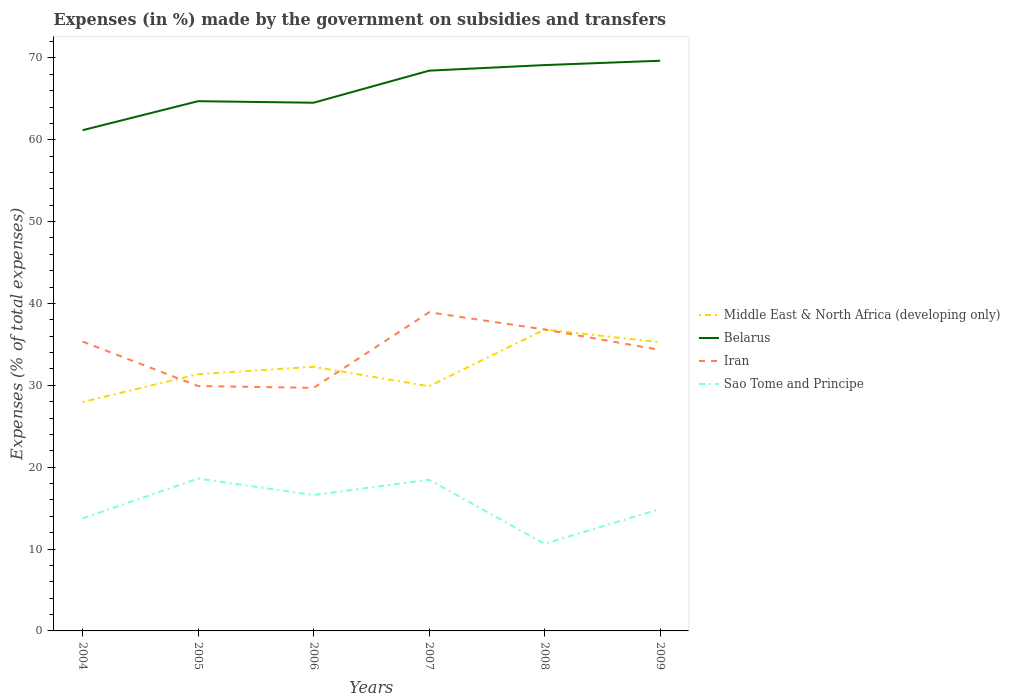How many different coloured lines are there?
Give a very brief answer. 4. Across all years, what is the maximum percentage of expenses made by the government on subsidies and transfers in Sao Tome and Principe?
Offer a very short reply. 10.63. What is the total percentage of expenses made by the government on subsidies and transfers in Iran in the graph?
Your answer should be very brief. -7.13. What is the difference between the highest and the second highest percentage of expenses made by the government on subsidies and transfers in Middle East & North Africa (developing only)?
Offer a very short reply. 8.86. How many lines are there?
Your answer should be compact. 4. How many years are there in the graph?
Provide a succinct answer. 6. Does the graph contain any zero values?
Ensure brevity in your answer.  No. Where does the legend appear in the graph?
Your answer should be very brief. Center right. How many legend labels are there?
Your response must be concise. 4. What is the title of the graph?
Provide a succinct answer. Expenses (in %) made by the government on subsidies and transfers. Does "Palau" appear as one of the legend labels in the graph?
Provide a short and direct response. No. What is the label or title of the X-axis?
Offer a very short reply. Years. What is the label or title of the Y-axis?
Ensure brevity in your answer.  Expenses (% of total expenses). What is the Expenses (% of total expenses) in Middle East & North Africa (developing only) in 2004?
Your answer should be very brief. 27.96. What is the Expenses (% of total expenses) in Belarus in 2004?
Make the answer very short. 61.16. What is the Expenses (% of total expenses) in Iran in 2004?
Your answer should be very brief. 35.34. What is the Expenses (% of total expenses) of Sao Tome and Principe in 2004?
Keep it short and to the point. 13.74. What is the Expenses (% of total expenses) of Middle East & North Africa (developing only) in 2005?
Keep it short and to the point. 31.37. What is the Expenses (% of total expenses) in Belarus in 2005?
Your answer should be very brief. 64.71. What is the Expenses (% of total expenses) in Iran in 2005?
Ensure brevity in your answer.  29.91. What is the Expenses (% of total expenses) in Sao Tome and Principe in 2005?
Provide a succinct answer. 18.61. What is the Expenses (% of total expenses) in Middle East & North Africa (developing only) in 2006?
Your answer should be very brief. 32.26. What is the Expenses (% of total expenses) of Belarus in 2006?
Offer a terse response. 64.52. What is the Expenses (% of total expenses) in Iran in 2006?
Your response must be concise. 29.69. What is the Expenses (% of total expenses) in Sao Tome and Principe in 2006?
Offer a terse response. 16.6. What is the Expenses (% of total expenses) of Middle East & North Africa (developing only) in 2007?
Your answer should be compact. 29.88. What is the Expenses (% of total expenses) in Belarus in 2007?
Offer a very short reply. 68.44. What is the Expenses (% of total expenses) of Iran in 2007?
Keep it short and to the point. 38.93. What is the Expenses (% of total expenses) of Sao Tome and Principe in 2007?
Make the answer very short. 18.47. What is the Expenses (% of total expenses) in Middle East & North Africa (developing only) in 2008?
Your response must be concise. 36.82. What is the Expenses (% of total expenses) in Belarus in 2008?
Make the answer very short. 69.12. What is the Expenses (% of total expenses) of Iran in 2008?
Keep it short and to the point. 36.82. What is the Expenses (% of total expenses) in Sao Tome and Principe in 2008?
Give a very brief answer. 10.63. What is the Expenses (% of total expenses) of Middle East & North Africa (developing only) in 2009?
Your answer should be compact. 35.26. What is the Expenses (% of total expenses) in Belarus in 2009?
Offer a very short reply. 69.65. What is the Expenses (% of total expenses) in Iran in 2009?
Your answer should be very brief. 34.32. What is the Expenses (% of total expenses) of Sao Tome and Principe in 2009?
Give a very brief answer. 14.9. Across all years, what is the maximum Expenses (% of total expenses) in Middle East & North Africa (developing only)?
Your answer should be very brief. 36.82. Across all years, what is the maximum Expenses (% of total expenses) of Belarus?
Offer a terse response. 69.65. Across all years, what is the maximum Expenses (% of total expenses) in Iran?
Your answer should be very brief. 38.93. Across all years, what is the maximum Expenses (% of total expenses) of Sao Tome and Principe?
Provide a short and direct response. 18.61. Across all years, what is the minimum Expenses (% of total expenses) in Middle East & North Africa (developing only)?
Provide a short and direct response. 27.96. Across all years, what is the minimum Expenses (% of total expenses) in Belarus?
Your answer should be very brief. 61.16. Across all years, what is the minimum Expenses (% of total expenses) of Iran?
Offer a very short reply. 29.69. Across all years, what is the minimum Expenses (% of total expenses) in Sao Tome and Principe?
Make the answer very short. 10.63. What is the total Expenses (% of total expenses) in Middle East & North Africa (developing only) in the graph?
Make the answer very short. 193.56. What is the total Expenses (% of total expenses) in Belarus in the graph?
Give a very brief answer. 397.61. What is the total Expenses (% of total expenses) of Iran in the graph?
Provide a short and direct response. 205.01. What is the total Expenses (% of total expenses) of Sao Tome and Principe in the graph?
Your response must be concise. 92.95. What is the difference between the Expenses (% of total expenses) of Middle East & North Africa (developing only) in 2004 and that in 2005?
Give a very brief answer. -3.4. What is the difference between the Expenses (% of total expenses) in Belarus in 2004 and that in 2005?
Provide a short and direct response. -3.55. What is the difference between the Expenses (% of total expenses) of Iran in 2004 and that in 2005?
Your answer should be compact. 5.43. What is the difference between the Expenses (% of total expenses) of Sao Tome and Principe in 2004 and that in 2005?
Your answer should be compact. -4.87. What is the difference between the Expenses (% of total expenses) of Middle East & North Africa (developing only) in 2004 and that in 2006?
Keep it short and to the point. -4.3. What is the difference between the Expenses (% of total expenses) in Belarus in 2004 and that in 2006?
Your answer should be compact. -3.36. What is the difference between the Expenses (% of total expenses) of Iran in 2004 and that in 2006?
Make the answer very short. 5.65. What is the difference between the Expenses (% of total expenses) in Sao Tome and Principe in 2004 and that in 2006?
Your answer should be very brief. -2.85. What is the difference between the Expenses (% of total expenses) in Middle East & North Africa (developing only) in 2004 and that in 2007?
Ensure brevity in your answer.  -1.92. What is the difference between the Expenses (% of total expenses) in Belarus in 2004 and that in 2007?
Provide a short and direct response. -7.28. What is the difference between the Expenses (% of total expenses) in Iran in 2004 and that in 2007?
Your answer should be very brief. -3.58. What is the difference between the Expenses (% of total expenses) in Sao Tome and Principe in 2004 and that in 2007?
Your answer should be very brief. -4.73. What is the difference between the Expenses (% of total expenses) in Middle East & North Africa (developing only) in 2004 and that in 2008?
Ensure brevity in your answer.  -8.86. What is the difference between the Expenses (% of total expenses) in Belarus in 2004 and that in 2008?
Ensure brevity in your answer.  -7.96. What is the difference between the Expenses (% of total expenses) in Iran in 2004 and that in 2008?
Provide a succinct answer. -1.48. What is the difference between the Expenses (% of total expenses) of Sao Tome and Principe in 2004 and that in 2008?
Provide a short and direct response. 3.11. What is the difference between the Expenses (% of total expenses) of Middle East & North Africa (developing only) in 2004 and that in 2009?
Make the answer very short. -7.3. What is the difference between the Expenses (% of total expenses) of Belarus in 2004 and that in 2009?
Ensure brevity in your answer.  -8.49. What is the difference between the Expenses (% of total expenses) in Iran in 2004 and that in 2009?
Offer a terse response. 1.03. What is the difference between the Expenses (% of total expenses) in Sao Tome and Principe in 2004 and that in 2009?
Keep it short and to the point. -1.15. What is the difference between the Expenses (% of total expenses) in Middle East & North Africa (developing only) in 2005 and that in 2006?
Make the answer very short. -0.9. What is the difference between the Expenses (% of total expenses) of Belarus in 2005 and that in 2006?
Your response must be concise. 0.19. What is the difference between the Expenses (% of total expenses) in Iran in 2005 and that in 2006?
Your answer should be very brief. 0.22. What is the difference between the Expenses (% of total expenses) of Sao Tome and Principe in 2005 and that in 2006?
Ensure brevity in your answer.  2.01. What is the difference between the Expenses (% of total expenses) in Middle East & North Africa (developing only) in 2005 and that in 2007?
Your answer should be very brief. 1.48. What is the difference between the Expenses (% of total expenses) of Belarus in 2005 and that in 2007?
Your response must be concise. -3.73. What is the difference between the Expenses (% of total expenses) of Iran in 2005 and that in 2007?
Provide a succinct answer. -9.01. What is the difference between the Expenses (% of total expenses) in Sao Tome and Principe in 2005 and that in 2007?
Your answer should be very brief. 0.14. What is the difference between the Expenses (% of total expenses) in Middle East & North Africa (developing only) in 2005 and that in 2008?
Your answer should be compact. -5.45. What is the difference between the Expenses (% of total expenses) in Belarus in 2005 and that in 2008?
Provide a succinct answer. -4.41. What is the difference between the Expenses (% of total expenses) of Iran in 2005 and that in 2008?
Your answer should be very brief. -6.91. What is the difference between the Expenses (% of total expenses) in Sao Tome and Principe in 2005 and that in 2008?
Offer a terse response. 7.98. What is the difference between the Expenses (% of total expenses) in Middle East & North Africa (developing only) in 2005 and that in 2009?
Ensure brevity in your answer.  -3.89. What is the difference between the Expenses (% of total expenses) of Belarus in 2005 and that in 2009?
Provide a short and direct response. -4.94. What is the difference between the Expenses (% of total expenses) in Iran in 2005 and that in 2009?
Your answer should be compact. -4.4. What is the difference between the Expenses (% of total expenses) in Sao Tome and Principe in 2005 and that in 2009?
Make the answer very short. 3.71. What is the difference between the Expenses (% of total expenses) of Middle East & North Africa (developing only) in 2006 and that in 2007?
Make the answer very short. 2.38. What is the difference between the Expenses (% of total expenses) of Belarus in 2006 and that in 2007?
Your response must be concise. -3.92. What is the difference between the Expenses (% of total expenses) in Iran in 2006 and that in 2007?
Offer a terse response. -9.23. What is the difference between the Expenses (% of total expenses) in Sao Tome and Principe in 2006 and that in 2007?
Provide a succinct answer. -1.87. What is the difference between the Expenses (% of total expenses) of Middle East & North Africa (developing only) in 2006 and that in 2008?
Ensure brevity in your answer.  -4.56. What is the difference between the Expenses (% of total expenses) of Belarus in 2006 and that in 2008?
Provide a short and direct response. -4.6. What is the difference between the Expenses (% of total expenses) in Iran in 2006 and that in 2008?
Ensure brevity in your answer.  -7.13. What is the difference between the Expenses (% of total expenses) in Sao Tome and Principe in 2006 and that in 2008?
Provide a short and direct response. 5.96. What is the difference between the Expenses (% of total expenses) of Middle East & North Africa (developing only) in 2006 and that in 2009?
Keep it short and to the point. -3. What is the difference between the Expenses (% of total expenses) in Belarus in 2006 and that in 2009?
Ensure brevity in your answer.  -5.13. What is the difference between the Expenses (% of total expenses) in Iran in 2006 and that in 2009?
Give a very brief answer. -4.62. What is the difference between the Expenses (% of total expenses) in Sao Tome and Principe in 2006 and that in 2009?
Give a very brief answer. 1.7. What is the difference between the Expenses (% of total expenses) in Middle East & North Africa (developing only) in 2007 and that in 2008?
Your answer should be compact. -6.94. What is the difference between the Expenses (% of total expenses) in Belarus in 2007 and that in 2008?
Offer a terse response. -0.68. What is the difference between the Expenses (% of total expenses) of Iran in 2007 and that in 2008?
Offer a terse response. 2.1. What is the difference between the Expenses (% of total expenses) of Sao Tome and Principe in 2007 and that in 2008?
Keep it short and to the point. 7.84. What is the difference between the Expenses (% of total expenses) in Middle East & North Africa (developing only) in 2007 and that in 2009?
Ensure brevity in your answer.  -5.38. What is the difference between the Expenses (% of total expenses) in Belarus in 2007 and that in 2009?
Keep it short and to the point. -1.21. What is the difference between the Expenses (% of total expenses) of Iran in 2007 and that in 2009?
Your answer should be compact. 4.61. What is the difference between the Expenses (% of total expenses) in Sao Tome and Principe in 2007 and that in 2009?
Ensure brevity in your answer.  3.57. What is the difference between the Expenses (% of total expenses) of Middle East & North Africa (developing only) in 2008 and that in 2009?
Keep it short and to the point. 1.56. What is the difference between the Expenses (% of total expenses) in Belarus in 2008 and that in 2009?
Your answer should be very brief. -0.53. What is the difference between the Expenses (% of total expenses) of Iran in 2008 and that in 2009?
Your response must be concise. 2.5. What is the difference between the Expenses (% of total expenses) in Sao Tome and Principe in 2008 and that in 2009?
Give a very brief answer. -4.26. What is the difference between the Expenses (% of total expenses) in Middle East & North Africa (developing only) in 2004 and the Expenses (% of total expenses) in Belarus in 2005?
Ensure brevity in your answer.  -36.75. What is the difference between the Expenses (% of total expenses) of Middle East & North Africa (developing only) in 2004 and the Expenses (% of total expenses) of Iran in 2005?
Your answer should be compact. -1.95. What is the difference between the Expenses (% of total expenses) in Middle East & North Africa (developing only) in 2004 and the Expenses (% of total expenses) in Sao Tome and Principe in 2005?
Provide a short and direct response. 9.36. What is the difference between the Expenses (% of total expenses) in Belarus in 2004 and the Expenses (% of total expenses) in Iran in 2005?
Offer a terse response. 31.25. What is the difference between the Expenses (% of total expenses) in Belarus in 2004 and the Expenses (% of total expenses) in Sao Tome and Principe in 2005?
Your answer should be very brief. 42.56. What is the difference between the Expenses (% of total expenses) in Iran in 2004 and the Expenses (% of total expenses) in Sao Tome and Principe in 2005?
Make the answer very short. 16.74. What is the difference between the Expenses (% of total expenses) of Middle East & North Africa (developing only) in 2004 and the Expenses (% of total expenses) of Belarus in 2006?
Your answer should be compact. -36.56. What is the difference between the Expenses (% of total expenses) in Middle East & North Africa (developing only) in 2004 and the Expenses (% of total expenses) in Iran in 2006?
Give a very brief answer. -1.73. What is the difference between the Expenses (% of total expenses) of Middle East & North Africa (developing only) in 2004 and the Expenses (% of total expenses) of Sao Tome and Principe in 2006?
Provide a short and direct response. 11.37. What is the difference between the Expenses (% of total expenses) in Belarus in 2004 and the Expenses (% of total expenses) in Iran in 2006?
Offer a terse response. 31.47. What is the difference between the Expenses (% of total expenses) of Belarus in 2004 and the Expenses (% of total expenses) of Sao Tome and Principe in 2006?
Ensure brevity in your answer.  44.57. What is the difference between the Expenses (% of total expenses) in Iran in 2004 and the Expenses (% of total expenses) in Sao Tome and Principe in 2006?
Ensure brevity in your answer.  18.75. What is the difference between the Expenses (% of total expenses) of Middle East & North Africa (developing only) in 2004 and the Expenses (% of total expenses) of Belarus in 2007?
Make the answer very short. -40.48. What is the difference between the Expenses (% of total expenses) in Middle East & North Africa (developing only) in 2004 and the Expenses (% of total expenses) in Iran in 2007?
Ensure brevity in your answer.  -10.96. What is the difference between the Expenses (% of total expenses) of Middle East & North Africa (developing only) in 2004 and the Expenses (% of total expenses) of Sao Tome and Principe in 2007?
Your answer should be compact. 9.49. What is the difference between the Expenses (% of total expenses) of Belarus in 2004 and the Expenses (% of total expenses) of Iran in 2007?
Your answer should be compact. 22.24. What is the difference between the Expenses (% of total expenses) of Belarus in 2004 and the Expenses (% of total expenses) of Sao Tome and Principe in 2007?
Your response must be concise. 42.69. What is the difference between the Expenses (% of total expenses) in Iran in 2004 and the Expenses (% of total expenses) in Sao Tome and Principe in 2007?
Your answer should be very brief. 16.88. What is the difference between the Expenses (% of total expenses) in Middle East & North Africa (developing only) in 2004 and the Expenses (% of total expenses) in Belarus in 2008?
Make the answer very short. -41.16. What is the difference between the Expenses (% of total expenses) in Middle East & North Africa (developing only) in 2004 and the Expenses (% of total expenses) in Iran in 2008?
Make the answer very short. -8.86. What is the difference between the Expenses (% of total expenses) of Middle East & North Africa (developing only) in 2004 and the Expenses (% of total expenses) of Sao Tome and Principe in 2008?
Provide a succinct answer. 17.33. What is the difference between the Expenses (% of total expenses) of Belarus in 2004 and the Expenses (% of total expenses) of Iran in 2008?
Make the answer very short. 24.34. What is the difference between the Expenses (% of total expenses) of Belarus in 2004 and the Expenses (% of total expenses) of Sao Tome and Principe in 2008?
Provide a short and direct response. 50.53. What is the difference between the Expenses (% of total expenses) of Iran in 2004 and the Expenses (% of total expenses) of Sao Tome and Principe in 2008?
Your response must be concise. 24.71. What is the difference between the Expenses (% of total expenses) of Middle East & North Africa (developing only) in 2004 and the Expenses (% of total expenses) of Belarus in 2009?
Ensure brevity in your answer.  -41.69. What is the difference between the Expenses (% of total expenses) of Middle East & North Africa (developing only) in 2004 and the Expenses (% of total expenses) of Iran in 2009?
Ensure brevity in your answer.  -6.35. What is the difference between the Expenses (% of total expenses) in Middle East & North Africa (developing only) in 2004 and the Expenses (% of total expenses) in Sao Tome and Principe in 2009?
Your answer should be compact. 13.07. What is the difference between the Expenses (% of total expenses) of Belarus in 2004 and the Expenses (% of total expenses) of Iran in 2009?
Your answer should be compact. 26.85. What is the difference between the Expenses (% of total expenses) in Belarus in 2004 and the Expenses (% of total expenses) in Sao Tome and Principe in 2009?
Offer a very short reply. 46.27. What is the difference between the Expenses (% of total expenses) of Iran in 2004 and the Expenses (% of total expenses) of Sao Tome and Principe in 2009?
Your answer should be very brief. 20.45. What is the difference between the Expenses (% of total expenses) of Middle East & North Africa (developing only) in 2005 and the Expenses (% of total expenses) of Belarus in 2006?
Give a very brief answer. -33.16. What is the difference between the Expenses (% of total expenses) in Middle East & North Africa (developing only) in 2005 and the Expenses (% of total expenses) in Iran in 2006?
Keep it short and to the point. 1.67. What is the difference between the Expenses (% of total expenses) in Middle East & North Africa (developing only) in 2005 and the Expenses (% of total expenses) in Sao Tome and Principe in 2006?
Give a very brief answer. 14.77. What is the difference between the Expenses (% of total expenses) of Belarus in 2005 and the Expenses (% of total expenses) of Iran in 2006?
Provide a succinct answer. 35.02. What is the difference between the Expenses (% of total expenses) of Belarus in 2005 and the Expenses (% of total expenses) of Sao Tome and Principe in 2006?
Ensure brevity in your answer.  48.11. What is the difference between the Expenses (% of total expenses) of Iran in 2005 and the Expenses (% of total expenses) of Sao Tome and Principe in 2006?
Provide a succinct answer. 13.32. What is the difference between the Expenses (% of total expenses) of Middle East & North Africa (developing only) in 2005 and the Expenses (% of total expenses) of Belarus in 2007?
Offer a very short reply. -37.07. What is the difference between the Expenses (% of total expenses) in Middle East & North Africa (developing only) in 2005 and the Expenses (% of total expenses) in Iran in 2007?
Ensure brevity in your answer.  -7.56. What is the difference between the Expenses (% of total expenses) in Middle East & North Africa (developing only) in 2005 and the Expenses (% of total expenses) in Sao Tome and Principe in 2007?
Give a very brief answer. 12.9. What is the difference between the Expenses (% of total expenses) of Belarus in 2005 and the Expenses (% of total expenses) of Iran in 2007?
Offer a terse response. 25.78. What is the difference between the Expenses (% of total expenses) of Belarus in 2005 and the Expenses (% of total expenses) of Sao Tome and Principe in 2007?
Your answer should be very brief. 46.24. What is the difference between the Expenses (% of total expenses) of Iran in 2005 and the Expenses (% of total expenses) of Sao Tome and Principe in 2007?
Give a very brief answer. 11.44. What is the difference between the Expenses (% of total expenses) in Middle East & North Africa (developing only) in 2005 and the Expenses (% of total expenses) in Belarus in 2008?
Ensure brevity in your answer.  -37.75. What is the difference between the Expenses (% of total expenses) of Middle East & North Africa (developing only) in 2005 and the Expenses (% of total expenses) of Iran in 2008?
Keep it short and to the point. -5.45. What is the difference between the Expenses (% of total expenses) in Middle East & North Africa (developing only) in 2005 and the Expenses (% of total expenses) in Sao Tome and Principe in 2008?
Provide a succinct answer. 20.73. What is the difference between the Expenses (% of total expenses) in Belarus in 2005 and the Expenses (% of total expenses) in Iran in 2008?
Ensure brevity in your answer.  27.89. What is the difference between the Expenses (% of total expenses) of Belarus in 2005 and the Expenses (% of total expenses) of Sao Tome and Principe in 2008?
Your response must be concise. 54.08. What is the difference between the Expenses (% of total expenses) in Iran in 2005 and the Expenses (% of total expenses) in Sao Tome and Principe in 2008?
Keep it short and to the point. 19.28. What is the difference between the Expenses (% of total expenses) in Middle East & North Africa (developing only) in 2005 and the Expenses (% of total expenses) in Belarus in 2009?
Offer a terse response. -38.28. What is the difference between the Expenses (% of total expenses) of Middle East & North Africa (developing only) in 2005 and the Expenses (% of total expenses) of Iran in 2009?
Your response must be concise. -2.95. What is the difference between the Expenses (% of total expenses) in Middle East & North Africa (developing only) in 2005 and the Expenses (% of total expenses) in Sao Tome and Principe in 2009?
Give a very brief answer. 16.47. What is the difference between the Expenses (% of total expenses) of Belarus in 2005 and the Expenses (% of total expenses) of Iran in 2009?
Give a very brief answer. 30.39. What is the difference between the Expenses (% of total expenses) of Belarus in 2005 and the Expenses (% of total expenses) of Sao Tome and Principe in 2009?
Keep it short and to the point. 49.81. What is the difference between the Expenses (% of total expenses) in Iran in 2005 and the Expenses (% of total expenses) in Sao Tome and Principe in 2009?
Give a very brief answer. 15.02. What is the difference between the Expenses (% of total expenses) in Middle East & North Africa (developing only) in 2006 and the Expenses (% of total expenses) in Belarus in 2007?
Make the answer very short. -36.17. What is the difference between the Expenses (% of total expenses) of Middle East & North Africa (developing only) in 2006 and the Expenses (% of total expenses) of Iran in 2007?
Make the answer very short. -6.66. What is the difference between the Expenses (% of total expenses) of Middle East & North Africa (developing only) in 2006 and the Expenses (% of total expenses) of Sao Tome and Principe in 2007?
Your answer should be compact. 13.79. What is the difference between the Expenses (% of total expenses) in Belarus in 2006 and the Expenses (% of total expenses) in Iran in 2007?
Make the answer very short. 25.6. What is the difference between the Expenses (% of total expenses) in Belarus in 2006 and the Expenses (% of total expenses) in Sao Tome and Principe in 2007?
Give a very brief answer. 46.05. What is the difference between the Expenses (% of total expenses) of Iran in 2006 and the Expenses (% of total expenses) of Sao Tome and Principe in 2007?
Make the answer very short. 11.22. What is the difference between the Expenses (% of total expenses) in Middle East & North Africa (developing only) in 2006 and the Expenses (% of total expenses) in Belarus in 2008?
Offer a very short reply. -36.86. What is the difference between the Expenses (% of total expenses) in Middle East & North Africa (developing only) in 2006 and the Expenses (% of total expenses) in Iran in 2008?
Offer a very short reply. -4.56. What is the difference between the Expenses (% of total expenses) of Middle East & North Africa (developing only) in 2006 and the Expenses (% of total expenses) of Sao Tome and Principe in 2008?
Offer a very short reply. 21.63. What is the difference between the Expenses (% of total expenses) in Belarus in 2006 and the Expenses (% of total expenses) in Iran in 2008?
Provide a succinct answer. 27.7. What is the difference between the Expenses (% of total expenses) in Belarus in 2006 and the Expenses (% of total expenses) in Sao Tome and Principe in 2008?
Provide a succinct answer. 53.89. What is the difference between the Expenses (% of total expenses) in Iran in 2006 and the Expenses (% of total expenses) in Sao Tome and Principe in 2008?
Your response must be concise. 19.06. What is the difference between the Expenses (% of total expenses) in Middle East & North Africa (developing only) in 2006 and the Expenses (% of total expenses) in Belarus in 2009?
Your response must be concise. -37.39. What is the difference between the Expenses (% of total expenses) in Middle East & North Africa (developing only) in 2006 and the Expenses (% of total expenses) in Iran in 2009?
Give a very brief answer. -2.05. What is the difference between the Expenses (% of total expenses) in Middle East & North Africa (developing only) in 2006 and the Expenses (% of total expenses) in Sao Tome and Principe in 2009?
Your answer should be very brief. 17.37. What is the difference between the Expenses (% of total expenses) of Belarus in 2006 and the Expenses (% of total expenses) of Iran in 2009?
Ensure brevity in your answer.  30.21. What is the difference between the Expenses (% of total expenses) in Belarus in 2006 and the Expenses (% of total expenses) in Sao Tome and Principe in 2009?
Provide a short and direct response. 49.63. What is the difference between the Expenses (% of total expenses) of Iran in 2006 and the Expenses (% of total expenses) of Sao Tome and Principe in 2009?
Offer a very short reply. 14.8. What is the difference between the Expenses (% of total expenses) of Middle East & North Africa (developing only) in 2007 and the Expenses (% of total expenses) of Belarus in 2008?
Offer a terse response. -39.24. What is the difference between the Expenses (% of total expenses) of Middle East & North Africa (developing only) in 2007 and the Expenses (% of total expenses) of Iran in 2008?
Provide a short and direct response. -6.94. What is the difference between the Expenses (% of total expenses) in Middle East & North Africa (developing only) in 2007 and the Expenses (% of total expenses) in Sao Tome and Principe in 2008?
Ensure brevity in your answer.  19.25. What is the difference between the Expenses (% of total expenses) in Belarus in 2007 and the Expenses (% of total expenses) in Iran in 2008?
Provide a short and direct response. 31.62. What is the difference between the Expenses (% of total expenses) of Belarus in 2007 and the Expenses (% of total expenses) of Sao Tome and Principe in 2008?
Ensure brevity in your answer.  57.81. What is the difference between the Expenses (% of total expenses) in Iran in 2007 and the Expenses (% of total expenses) in Sao Tome and Principe in 2008?
Your answer should be compact. 28.29. What is the difference between the Expenses (% of total expenses) in Middle East & North Africa (developing only) in 2007 and the Expenses (% of total expenses) in Belarus in 2009?
Keep it short and to the point. -39.77. What is the difference between the Expenses (% of total expenses) of Middle East & North Africa (developing only) in 2007 and the Expenses (% of total expenses) of Iran in 2009?
Your answer should be compact. -4.43. What is the difference between the Expenses (% of total expenses) of Middle East & North Africa (developing only) in 2007 and the Expenses (% of total expenses) of Sao Tome and Principe in 2009?
Give a very brief answer. 14.99. What is the difference between the Expenses (% of total expenses) in Belarus in 2007 and the Expenses (% of total expenses) in Iran in 2009?
Keep it short and to the point. 34.12. What is the difference between the Expenses (% of total expenses) in Belarus in 2007 and the Expenses (% of total expenses) in Sao Tome and Principe in 2009?
Provide a succinct answer. 53.54. What is the difference between the Expenses (% of total expenses) in Iran in 2007 and the Expenses (% of total expenses) in Sao Tome and Principe in 2009?
Give a very brief answer. 24.03. What is the difference between the Expenses (% of total expenses) in Middle East & North Africa (developing only) in 2008 and the Expenses (% of total expenses) in Belarus in 2009?
Your answer should be very brief. -32.83. What is the difference between the Expenses (% of total expenses) in Middle East & North Africa (developing only) in 2008 and the Expenses (% of total expenses) in Iran in 2009?
Your response must be concise. 2.5. What is the difference between the Expenses (% of total expenses) of Middle East & North Africa (developing only) in 2008 and the Expenses (% of total expenses) of Sao Tome and Principe in 2009?
Offer a very short reply. 21.92. What is the difference between the Expenses (% of total expenses) of Belarus in 2008 and the Expenses (% of total expenses) of Iran in 2009?
Offer a very short reply. 34.8. What is the difference between the Expenses (% of total expenses) of Belarus in 2008 and the Expenses (% of total expenses) of Sao Tome and Principe in 2009?
Provide a short and direct response. 54.22. What is the difference between the Expenses (% of total expenses) of Iran in 2008 and the Expenses (% of total expenses) of Sao Tome and Principe in 2009?
Your answer should be very brief. 21.92. What is the average Expenses (% of total expenses) of Middle East & North Africa (developing only) per year?
Offer a very short reply. 32.26. What is the average Expenses (% of total expenses) of Belarus per year?
Keep it short and to the point. 66.27. What is the average Expenses (% of total expenses) of Iran per year?
Ensure brevity in your answer.  34.17. What is the average Expenses (% of total expenses) of Sao Tome and Principe per year?
Keep it short and to the point. 15.49. In the year 2004, what is the difference between the Expenses (% of total expenses) in Middle East & North Africa (developing only) and Expenses (% of total expenses) in Belarus?
Provide a succinct answer. -33.2. In the year 2004, what is the difference between the Expenses (% of total expenses) of Middle East & North Africa (developing only) and Expenses (% of total expenses) of Iran?
Keep it short and to the point. -7.38. In the year 2004, what is the difference between the Expenses (% of total expenses) in Middle East & North Africa (developing only) and Expenses (% of total expenses) in Sao Tome and Principe?
Your answer should be very brief. 14.22. In the year 2004, what is the difference between the Expenses (% of total expenses) of Belarus and Expenses (% of total expenses) of Iran?
Give a very brief answer. 25.82. In the year 2004, what is the difference between the Expenses (% of total expenses) of Belarus and Expenses (% of total expenses) of Sao Tome and Principe?
Offer a terse response. 47.42. In the year 2004, what is the difference between the Expenses (% of total expenses) of Iran and Expenses (% of total expenses) of Sao Tome and Principe?
Offer a terse response. 21.6. In the year 2005, what is the difference between the Expenses (% of total expenses) in Middle East & North Africa (developing only) and Expenses (% of total expenses) in Belarus?
Make the answer very short. -33.34. In the year 2005, what is the difference between the Expenses (% of total expenses) in Middle East & North Africa (developing only) and Expenses (% of total expenses) in Iran?
Offer a very short reply. 1.45. In the year 2005, what is the difference between the Expenses (% of total expenses) in Middle East & North Africa (developing only) and Expenses (% of total expenses) in Sao Tome and Principe?
Your response must be concise. 12.76. In the year 2005, what is the difference between the Expenses (% of total expenses) in Belarus and Expenses (% of total expenses) in Iran?
Your response must be concise. 34.8. In the year 2005, what is the difference between the Expenses (% of total expenses) of Belarus and Expenses (% of total expenses) of Sao Tome and Principe?
Provide a short and direct response. 46.1. In the year 2005, what is the difference between the Expenses (% of total expenses) in Iran and Expenses (% of total expenses) in Sao Tome and Principe?
Your answer should be very brief. 11.3. In the year 2006, what is the difference between the Expenses (% of total expenses) of Middle East & North Africa (developing only) and Expenses (% of total expenses) of Belarus?
Your answer should be compact. -32.26. In the year 2006, what is the difference between the Expenses (% of total expenses) in Middle East & North Africa (developing only) and Expenses (% of total expenses) in Iran?
Offer a terse response. 2.57. In the year 2006, what is the difference between the Expenses (% of total expenses) in Middle East & North Africa (developing only) and Expenses (% of total expenses) in Sao Tome and Principe?
Give a very brief answer. 15.67. In the year 2006, what is the difference between the Expenses (% of total expenses) of Belarus and Expenses (% of total expenses) of Iran?
Offer a very short reply. 34.83. In the year 2006, what is the difference between the Expenses (% of total expenses) in Belarus and Expenses (% of total expenses) in Sao Tome and Principe?
Ensure brevity in your answer.  47.93. In the year 2006, what is the difference between the Expenses (% of total expenses) in Iran and Expenses (% of total expenses) in Sao Tome and Principe?
Your response must be concise. 13.09. In the year 2007, what is the difference between the Expenses (% of total expenses) in Middle East & North Africa (developing only) and Expenses (% of total expenses) in Belarus?
Keep it short and to the point. -38.55. In the year 2007, what is the difference between the Expenses (% of total expenses) in Middle East & North Africa (developing only) and Expenses (% of total expenses) in Iran?
Your response must be concise. -9.04. In the year 2007, what is the difference between the Expenses (% of total expenses) in Middle East & North Africa (developing only) and Expenses (% of total expenses) in Sao Tome and Principe?
Ensure brevity in your answer.  11.41. In the year 2007, what is the difference between the Expenses (% of total expenses) in Belarus and Expenses (% of total expenses) in Iran?
Your response must be concise. 29.51. In the year 2007, what is the difference between the Expenses (% of total expenses) in Belarus and Expenses (% of total expenses) in Sao Tome and Principe?
Your answer should be compact. 49.97. In the year 2007, what is the difference between the Expenses (% of total expenses) in Iran and Expenses (% of total expenses) in Sao Tome and Principe?
Make the answer very short. 20.46. In the year 2008, what is the difference between the Expenses (% of total expenses) of Middle East & North Africa (developing only) and Expenses (% of total expenses) of Belarus?
Your response must be concise. -32.3. In the year 2008, what is the difference between the Expenses (% of total expenses) in Middle East & North Africa (developing only) and Expenses (% of total expenses) in Sao Tome and Principe?
Your answer should be compact. 26.19. In the year 2008, what is the difference between the Expenses (% of total expenses) of Belarus and Expenses (% of total expenses) of Iran?
Keep it short and to the point. 32.3. In the year 2008, what is the difference between the Expenses (% of total expenses) in Belarus and Expenses (% of total expenses) in Sao Tome and Principe?
Your answer should be very brief. 58.49. In the year 2008, what is the difference between the Expenses (% of total expenses) of Iran and Expenses (% of total expenses) of Sao Tome and Principe?
Your answer should be very brief. 26.19. In the year 2009, what is the difference between the Expenses (% of total expenses) in Middle East & North Africa (developing only) and Expenses (% of total expenses) in Belarus?
Your answer should be very brief. -34.39. In the year 2009, what is the difference between the Expenses (% of total expenses) of Middle East & North Africa (developing only) and Expenses (% of total expenses) of Iran?
Provide a succinct answer. 0.94. In the year 2009, what is the difference between the Expenses (% of total expenses) of Middle East & North Africa (developing only) and Expenses (% of total expenses) of Sao Tome and Principe?
Make the answer very short. 20.36. In the year 2009, what is the difference between the Expenses (% of total expenses) of Belarus and Expenses (% of total expenses) of Iran?
Your response must be concise. 35.34. In the year 2009, what is the difference between the Expenses (% of total expenses) of Belarus and Expenses (% of total expenses) of Sao Tome and Principe?
Your answer should be compact. 54.75. In the year 2009, what is the difference between the Expenses (% of total expenses) of Iran and Expenses (% of total expenses) of Sao Tome and Principe?
Offer a very short reply. 19.42. What is the ratio of the Expenses (% of total expenses) in Middle East & North Africa (developing only) in 2004 to that in 2005?
Make the answer very short. 0.89. What is the ratio of the Expenses (% of total expenses) in Belarus in 2004 to that in 2005?
Keep it short and to the point. 0.95. What is the ratio of the Expenses (% of total expenses) of Iran in 2004 to that in 2005?
Make the answer very short. 1.18. What is the ratio of the Expenses (% of total expenses) of Sao Tome and Principe in 2004 to that in 2005?
Your answer should be compact. 0.74. What is the ratio of the Expenses (% of total expenses) of Middle East & North Africa (developing only) in 2004 to that in 2006?
Make the answer very short. 0.87. What is the ratio of the Expenses (% of total expenses) of Belarus in 2004 to that in 2006?
Ensure brevity in your answer.  0.95. What is the ratio of the Expenses (% of total expenses) of Iran in 2004 to that in 2006?
Offer a terse response. 1.19. What is the ratio of the Expenses (% of total expenses) in Sao Tome and Principe in 2004 to that in 2006?
Ensure brevity in your answer.  0.83. What is the ratio of the Expenses (% of total expenses) of Middle East & North Africa (developing only) in 2004 to that in 2007?
Offer a terse response. 0.94. What is the ratio of the Expenses (% of total expenses) of Belarus in 2004 to that in 2007?
Give a very brief answer. 0.89. What is the ratio of the Expenses (% of total expenses) of Iran in 2004 to that in 2007?
Offer a terse response. 0.91. What is the ratio of the Expenses (% of total expenses) of Sao Tome and Principe in 2004 to that in 2007?
Offer a terse response. 0.74. What is the ratio of the Expenses (% of total expenses) of Middle East & North Africa (developing only) in 2004 to that in 2008?
Offer a very short reply. 0.76. What is the ratio of the Expenses (% of total expenses) in Belarus in 2004 to that in 2008?
Make the answer very short. 0.88. What is the ratio of the Expenses (% of total expenses) of Iran in 2004 to that in 2008?
Provide a succinct answer. 0.96. What is the ratio of the Expenses (% of total expenses) of Sao Tome and Principe in 2004 to that in 2008?
Provide a succinct answer. 1.29. What is the ratio of the Expenses (% of total expenses) in Middle East & North Africa (developing only) in 2004 to that in 2009?
Offer a terse response. 0.79. What is the ratio of the Expenses (% of total expenses) in Belarus in 2004 to that in 2009?
Your answer should be compact. 0.88. What is the ratio of the Expenses (% of total expenses) of Iran in 2004 to that in 2009?
Ensure brevity in your answer.  1.03. What is the ratio of the Expenses (% of total expenses) of Sao Tome and Principe in 2004 to that in 2009?
Your answer should be compact. 0.92. What is the ratio of the Expenses (% of total expenses) in Middle East & North Africa (developing only) in 2005 to that in 2006?
Give a very brief answer. 0.97. What is the ratio of the Expenses (% of total expenses) in Belarus in 2005 to that in 2006?
Provide a succinct answer. 1. What is the ratio of the Expenses (% of total expenses) of Iran in 2005 to that in 2006?
Provide a short and direct response. 1.01. What is the ratio of the Expenses (% of total expenses) of Sao Tome and Principe in 2005 to that in 2006?
Provide a succinct answer. 1.12. What is the ratio of the Expenses (% of total expenses) of Middle East & North Africa (developing only) in 2005 to that in 2007?
Make the answer very short. 1.05. What is the ratio of the Expenses (% of total expenses) in Belarus in 2005 to that in 2007?
Offer a very short reply. 0.95. What is the ratio of the Expenses (% of total expenses) in Iran in 2005 to that in 2007?
Ensure brevity in your answer.  0.77. What is the ratio of the Expenses (% of total expenses) of Sao Tome and Principe in 2005 to that in 2007?
Give a very brief answer. 1.01. What is the ratio of the Expenses (% of total expenses) in Middle East & North Africa (developing only) in 2005 to that in 2008?
Your answer should be compact. 0.85. What is the ratio of the Expenses (% of total expenses) of Belarus in 2005 to that in 2008?
Offer a terse response. 0.94. What is the ratio of the Expenses (% of total expenses) of Iran in 2005 to that in 2008?
Make the answer very short. 0.81. What is the ratio of the Expenses (% of total expenses) of Middle East & North Africa (developing only) in 2005 to that in 2009?
Offer a very short reply. 0.89. What is the ratio of the Expenses (% of total expenses) in Belarus in 2005 to that in 2009?
Ensure brevity in your answer.  0.93. What is the ratio of the Expenses (% of total expenses) in Iran in 2005 to that in 2009?
Keep it short and to the point. 0.87. What is the ratio of the Expenses (% of total expenses) in Sao Tome and Principe in 2005 to that in 2009?
Make the answer very short. 1.25. What is the ratio of the Expenses (% of total expenses) of Middle East & North Africa (developing only) in 2006 to that in 2007?
Make the answer very short. 1.08. What is the ratio of the Expenses (% of total expenses) of Belarus in 2006 to that in 2007?
Keep it short and to the point. 0.94. What is the ratio of the Expenses (% of total expenses) in Iran in 2006 to that in 2007?
Offer a terse response. 0.76. What is the ratio of the Expenses (% of total expenses) of Sao Tome and Principe in 2006 to that in 2007?
Provide a short and direct response. 0.9. What is the ratio of the Expenses (% of total expenses) of Middle East & North Africa (developing only) in 2006 to that in 2008?
Offer a terse response. 0.88. What is the ratio of the Expenses (% of total expenses) of Belarus in 2006 to that in 2008?
Your answer should be very brief. 0.93. What is the ratio of the Expenses (% of total expenses) of Iran in 2006 to that in 2008?
Make the answer very short. 0.81. What is the ratio of the Expenses (% of total expenses) of Sao Tome and Principe in 2006 to that in 2008?
Offer a terse response. 1.56. What is the ratio of the Expenses (% of total expenses) of Middle East & North Africa (developing only) in 2006 to that in 2009?
Offer a very short reply. 0.92. What is the ratio of the Expenses (% of total expenses) in Belarus in 2006 to that in 2009?
Your answer should be compact. 0.93. What is the ratio of the Expenses (% of total expenses) of Iran in 2006 to that in 2009?
Your answer should be compact. 0.87. What is the ratio of the Expenses (% of total expenses) in Sao Tome and Principe in 2006 to that in 2009?
Your response must be concise. 1.11. What is the ratio of the Expenses (% of total expenses) in Middle East & North Africa (developing only) in 2007 to that in 2008?
Make the answer very short. 0.81. What is the ratio of the Expenses (% of total expenses) in Belarus in 2007 to that in 2008?
Your answer should be compact. 0.99. What is the ratio of the Expenses (% of total expenses) of Iran in 2007 to that in 2008?
Your answer should be very brief. 1.06. What is the ratio of the Expenses (% of total expenses) of Sao Tome and Principe in 2007 to that in 2008?
Make the answer very short. 1.74. What is the ratio of the Expenses (% of total expenses) of Middle East & North Africa (developing only) in 2007 to that in 2009?
Make the answer very short. 0.85. What is the ratio of the Expenses (% of total expenses) of Belarus in 2007 to that in 2009?
Make the answer very short. 0.98. What is the ratio of the Expenses (% of total expenses) of Iran in 2007 to that in 2009?
Keep it short and to the point. 1.13. What is the ratio of the Expenses (% of total expenses) of Sao Tome and Principe in 2007 to that in 2009?
Provide a succinct answer. 1.24. What is the ratio of the Expenses (% of total expenses) in Middle East & North Africa (developing only) in 2008 to that in 2009?
Ensure brevity in your answer.  1.04. What is the ratio of the Expenses (% of total expenses) in Belarus in 2008 to that in 2009?
Your response must be concise. 0.99. What is the ratio of the Expenses (% of total expenses) of Iran in 2008 to that in 2009?
Your answer should be compact. 1.07. What is the ratio of the Expenses (% of total expenses) of Sao Tome and Principe in 2008 to that in 2009?
Offer a terse response. 0.71. What is the difference between the highest and the second highest Expenses (% of total expenses) in Middle East & North Africa (developing only)?
Your answer should be compact. 1.56. What is the difference between the highest and the second highest Expenses (% of total expenses) of Belarus?
Provide a succinct answer. 0.53. What is the difference between the highest and the second highest Expenses (% of total expenses) in Iran?
Provide a short and direct response. 2.1. What is the difference between the highest and the second highest Expenses (% of total expenses) in Sao Tome and Principe?
Offer a very short reply. 0.14. What is the difference between the highest and the lowest Expenses (% of total expenses) of Middle East & North Africa (developing only)?
Your response must be concise. 8.86. What is the difference between the highest and the lowest Expenses (% of total expenses) in Belarus?
Offer a very short reply. 8.49. What is the difference between the highest and the lowest Expenses (% of total expenses) in Iran?
Make the answer very short. 9.23. What is the difference between the highest and the lowest Expenses (% of total expenses) in Sao Tome and Principe?
Keep it short and to the point. 7.98. 